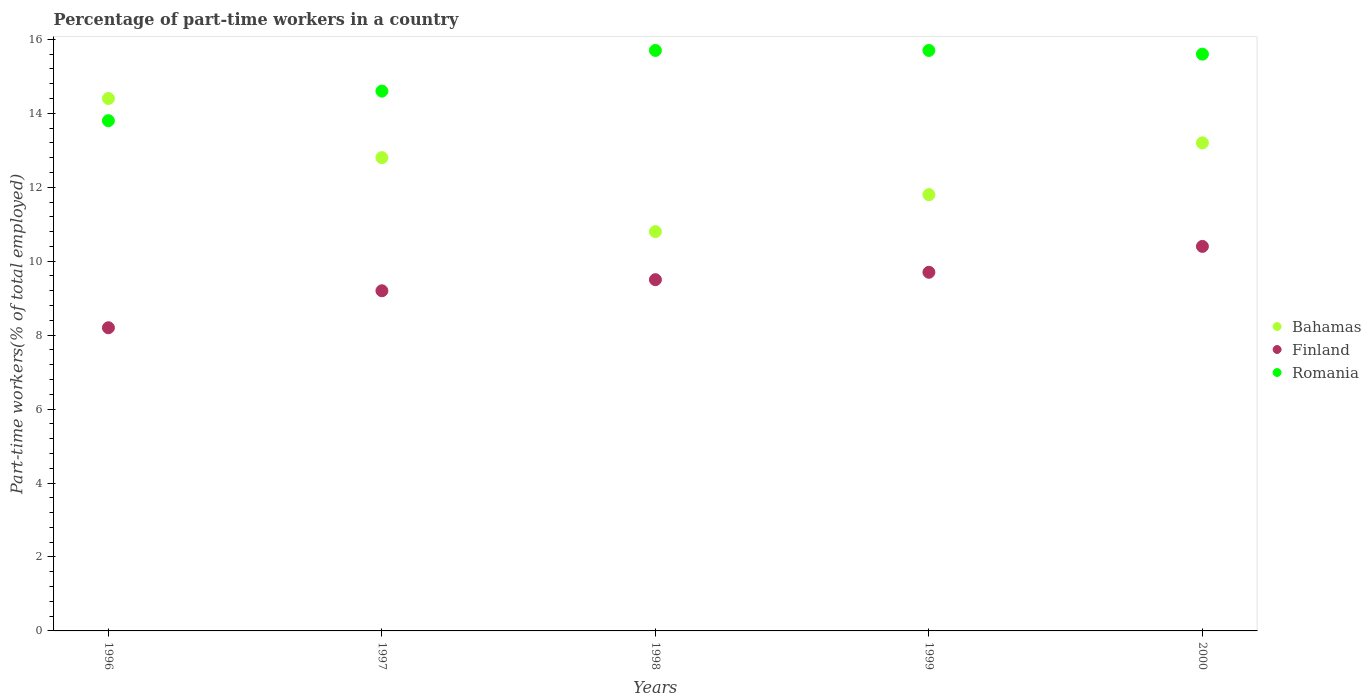Is the number of dotlines equal to the number of legend labels?
Offer a very short reply. Yes. What is the percentage of part-time workers in Bahamas in 1997?
Your response must be concise. 12.8. Across all years, what is the maximum percentage of part-time workers in Finland?
Give a very brief answer. 10.4. Across all years, what is the minimum percentage of part-time workers in Finland?
Offer a very short reply. 8.2. In which year was the percentage of part-time workers in Finland minimum?
Your answer should be very brief. 1996. What is the total percentage of part-time workers in Finland in the graph?
Give a very brief answer. 47. What is the difference between the percentage of part-time workers in Bahamas in 1996 and that in 1997?
Your response must be concise. 1.6. What is the difference between the percentage of part-time workers in Finland in 1998 and the percentage of part-time workers in Bahamas in 1997?
Provide a succinct answer. -3.3. What is the average percentage of part-time workers in Bahamas per year?
Make the answer very short. 12.6. In the year 1996, what is the difference between the percentage of part-time workers in Finland and percentage of part-time workers in Bahamas?
Ensure brevity in your answer.  -6.2. In how many years, is the percentage of part-time workers in Romania greater than 8.8 %?
Offer a very short reply. 5. What is the ratio of the percentage of part-time workers in Romania in 1997 to that in 1999?
Your answer should be very brief. 0.93. What is the difference between the highest and the second highest percentage of part-time workers in Romania?
Make the answer very short. 0. What is the difference between the highest and the lowest percentage of part-time workers in Romania?
Provide a succinct answer. 1.9. Is it the case that in every year, the sum of the percentage of part-time workers in Romania and percentage of part-time workers in Finland  is greater than the percentage of part-time workers in Bahamas?
Ensure brevity in your answer.  Yes. How many dotlines are there?
Your answer should be very brief. 3. What is the difference between two consecutive major ticks on the Y-axis?
Ensure brevity in your answer.  2. Are the values on the major ticks of Y-axis written in scientific E-notation?
Offer a terse response. No. Where does the legend appear in the graph?
Give a very brief answer. Center right. How many legend labels are there?
Your response must be concise. 3. What is the title of the graph?
Offer a terse response. Percentage of part-time workers in a country. What is the label or title of the X-axis?
Provide a succinct answer. Years. What is the label or title of the Y-axis?
Offer a very short reply. Part-time workers(% of total employed). What is the Part-time workers(% of total employed) in Bahamas in 1996?
Make the answer very short. 14.4. What is the Part-time workers(% of total employed) in Finland in 1996?
Provide a succinct answer. 8.2. What is the Part-time workers(% of total employed) in Romania in 1996?
Make the answer very short. 13.8. What is the Part-time workers(% of total employed) in Bahamas in 1997?
Offer a terse response. 12.8. What is the Part-time workers(% of total employed) of Finland in 1997?
Make the answer very short. 9.2. What is the Part-time workers(% of total employed) of Romania in 1997?
Provide a short and direct response. 14.6. What is the Part-time workers(% of total employed) in Bahamas in 1998?
Provide a succinct answer. 10.8. What is the Part-time workers(% of total employed) of Finland in 1998?
Provide a succinct answer. 9.5. What is the Part-time workers(% of total employed) of Romania in 1998?
Your response must be concise. 15.7. What is the Part-time workers(% of total employed) in Bahamas in 1999?
Make the answer very short. 11.8. What is the Part-time workers(% of total employed) of Finland in 1999?
Your answer should be compact. 9.7. What is the Part-time workers(% of total employed) in Romania in 1999?
Ensure brevity in your answer.  15.7. What is the Part-time workers(% of total employed) of Bahamas in 2000?
Your response must be concise. 13.2. What is the Part-time workers(% of total employed) in Finland in 2000?
Make the answer very short. 10.4. What is the Part-time workers(% of total employed) of Romania in 2000?
Your answer should be very brief. 15.6. Across all years, what is the maximum Part-time workers(% of total employed) of Bahamas?
Provide a succinct answer. 14.4. Across all years, what is the maximum Part-time workers(% of total employed) of Finland?
Keep it short and to the point. 10.4. Across all years, what is the maximum Part-time workers(% of total employed) in Romania?
Offer a terse response. 15.7. Across all years, what is the minimum Part-time workers(% of total employed) of Bahamas?
Ensure brevity in your answer.  10.8. Across all years, what is the minimum Part-time workers(% of total employed) of Finland?
Your answer should be very brief. 8.2. Across all years, what is the minimum Part-time workers(% of total employed) of Romania?
Your answer should be very brief. 13.8. What is the total Part-time workers(% of total employed) of Bahamas in the graph?
Keep it short and to the point. 63. What is the total Part-time workers(% of total employed) of Finland in the graph?
Provide a succinct answer. 47. What is the total Part-time workers(% of total employed) of Romania in the graph?
Give a very brief answer. 75.4. What is the difference between the Part-time workers(% of total employed) of Bahamas in 1996 and that in 1997?
Keep it short and to the point. 1.6. What is the difference between the Part-time workers(% of total employed) of Bahamas in 1996 and that in 1998?
Your answer should be compact. 3.6. What is the difference between the Part-time workers(% of total employed) in Finland in 1996 and that in 1998?
Ensure brevity in your answer.  -1.3. What is the difference between the Part-time workers(% of total employed) in Bahamas in 1996 and that in 2000?
Your response must be concise. 1.2. What is the difference between the Part-time workers(% of total employed) in Finland in 1996 and that in 2000?
Your answer should be very brief. -2.2. What is the difference between the Part-time workers(% of total employed) of Romania in 1996 and that in 2000?
Make the answer very short. -1.8. What is the difference between the Part-time workers(% of total employed) in Bahamas in 1997 and that in 1998?
Keep it short and to the point. 2. What is the difference between the Part-time workers(% of total employed) in Finland in 1997 and that in 1998?
Provide a succinct answer. -0.3. What is the difference between the Part-time workers(% of total employed) in Romania in 1997 and that in 1998?
Ensure brevity in your answer.  -1.1. What is the difference between the Part-time workers(% of total employed) of Finland in 1997 and that in 1999?
Make the answer very short. -0.5. What is the difference between the Part-time workers(% of total employed) in Romania in 1997 and that in 1999?
Offer a very short reply. -1.1. What is the difference between the Part-time workers(% of total employed) of Romania in 1997 and that in 2000?
Ensure brevity in your answer.  -1. What is the difference between the Part-time workers(% of total employed) of Bahamas in 1998 and that in 2000?
Keep it short and to the point. -2.4. What is the difference between the Part-time workers(% of total employed) in Romania in 1998 and that in 2000?
Provide a short and direct response. 0.1. What is the difference between the Part-time workers(% of total employed) of Bahamas in 1996 and the Part-time workers(% of total employed) of Finland in 1997?
Ensure brevity in your answer.  5.2. What is the difference between the Part-time workers(% of total employed) of Bahamas in 1996 and the Part-time workers(% of total employed) of Finland in 1998?
Offer a terse response. 4.9. What is the difference between the Part-time workers(% of total employed) of Bahamas in 1996 and the Part-time workers(% of total employed) of Romania in 1998?
Provide a short and direct response. -1.3. What is the difference between the Part-time workers(% of total employed) in Finland in 1996 and the Part-time workers(% of total employed) in Romania in 1999?
Offer a terse response. -7.5. What is the difference between the Part-time workers(% of total employed) of Finland in 1996 and the Part-time workers(% of total employed) of Romania in 2000?
Provide a succinct answer. -7.4. What is the difference between the Part-time workers(% of total employed) of Bahamas in 1997 and the Part-time workers(% of total employed) of Finland in 1998?
Provide a short and direct response. 3.3. What is the difference between the Part-time workers(% of total employed) of Finland in 1997 and the Part-time workers(% of total employed) of Romania in 1998?
Make the answer very short. -6.5. What is the difference between the Part-time workers(% of total employed) in Bahamas in 1997 and the Part-time workers(% of total employed) in Romania in 1999?
Your answer should be very brief. -2.9. What is the difference between the Part-time workers(% of total employed) in Finland in 1997 and the Part-time workers(% of total employed) in Romania in 1999?
Your response must be concise. -6.5. What is the difference between the Part-time workers(% of total employed) in Bahamas in 1997 and the Part-time workers(% of total employed) in Finland in 2000?
Your answer should be compact. 2.4. What is the difference between the Part-time workers(% of total employed) of Finland in 1998 and the Part-time workers(% of total employed) of Romania in 1999?
Offer a very short reply. -6.2. What is the difference between the Part-time workers(% of total employed) in Bahamas in 1998 and the Part-time workers(% of total employed) in Finland in 2000?
Your response must be concise. 0.4. What is the difference between the Part-time workers(% of total employed) in Finland in 1998 and the Part-time workers(% of total employed) in Romania in 2000?
Make the answer very short. -6.1. What is the difference between the Part-time workers(% of total employed) of Bahamas in 1999 and the Part-time workers(% of total employed) of Finland in 2000?
Give a very brief answer. 1.4. What is the average Part-time workers(% of total employed) of Romania per year?
Give a very brief answer. 15.08. In the year 1996, what is the difference between the Part-time workers(% of total employed) of Bahamas and Part-time workers(% of total employed) of Romania?
Provide a succinct answer. 0.6. In the year 1997, what is the difference between the Part-time workers(% of total employed) of Bahamas and Part-time workers(% of total employed) of Finland?
Your response must be concise. 3.6. In the year 1997, what is the difference between the Part-time workers(% of total employed) in Finland and Part-time workers(% of total employed) in Romania?
Give a very brief answer. -5.4. In the year 1998, what is the difference between the Part-time workers(% of total employed) in Bahamas and Part-time workers(% of total employed) in Finland?
Your response must be concise. 1.3. In the year 1999, what is the difference between the Part-time workers(% of total employed) of Bahamas and Part-time workers(% of total employed) of Romania?
Your answer should be very brief. -3.9. In the year 2000, what is the difference between the Part-time workers(% of total employed) of Bahamas and Part-time workers(% of total employed) of Romania?
Your answer should be very brief. -2.4. In the year 2000, what is the difference between the Part-time workers(% of total employed) in Finland and Part-time workers(% of total employed) in Romania?
Your answer should be very brief. -5.2. What is the ratio of the Part-time workers(% of total employed) in Finland in 1996 to that in 1997?
Offer a terse response. 0.89. What is the ratio of the Part-time workers(% of total employed) of Romania in 1996 to that in 1997?
Give a very brief answer. 0.95. What is the ratio of the Part-time workers(% of total employed) in Finland in 1996 to that in 1998?
Keep it short and to the point. 0.86. What is the ratio of the Part-time workers(% of total employed) in Romania in 1996 to that in 1998?
Keep it short and to the point. 0.88. What is the ratio of the Part-time workers(% of total employed) of Bahamas in 1996 to that in 1999?
Offer a very short reply. 1.22. What is the ratio of the Part-time workers(% of total employed) of Finland in 1996 to that in 1999?
Provide a succinct answer. 0.85. What is the ratio of the Part-time workers(% of total employed) of Romania in 1996 to that in 1999?
Make the answer very short. 0.88. What is the ratio of the Part-time workers(% of total employed) in Bahamas in 1996 to that in 2000?
Your answer should be compact. 1.09. What is the ratio of the Part-time workers(% of total employed) in Finland in 1996 to that in 2000?
Your response must be concise. 0.79. What is the ratio of the Part-time workers(% of total employed) in Romania in 1996 to that in 2000?
Keep it short and to the point. 0.88. What is the ratio of the Part-time workers(% of total employed) of Bahamas in 1997 to that in 1998?
Give a very brief answer. 1.19. What is the ratio of the Part-time workers(% of total employed) of Finland in 1997 to that in 1998?
Make the answer very short. 0.97. What is the ratio of the Part-time workers(% of total employed) of Romania in 1997 to that in 1998?
Ensure brevity in your answer.  0.93. What is the ratio of the Part-time workers(% of total employed) in Bahamas in 1997 to that in 1999?
Ensure brevity in your answer.  1.08. What is the ratio of the Part-time workers(% of total employed) in Finland in 1997 to that in 1999?
Offer a very short reply. 0.95. What is the ratio of the Part-time workers(% of total employed) in Romania in 1997 to that in 1999?
Provide a short and direct response. 0.93. What is the ratio of the Part-time workers(% of total employed) in Bahamas in 1997 to that in 2000?
Make the answer very short. 0.97. What is the ratio of the Part-time workers(% of total employed) in Finland in 1997 to that in 2000?
Offer a very short reply. 0.88. What is the ratio of the Part-time workers(% of total employed) of Romania in 1997 to that in 2000?
Make the answer very short. 0.94. What is the ratio of the Part-time workers(% of total employed) in Bahamas in 1998 to that in 1999?
Provide a succinct answer. 0.92. What is the ratio of the Part-time workers(% of total employed) in Finland in 1998 to that in 1999?
Your answer should be compact. 0.98. What is the ratio of the Part-time workers(% of total employed) in Romania in 1998 to that in 1999?
Your answer should be compact. 1. What is the ratio of the Part-time workers(% of total employed) in Bahamas in 1998 to that in 2000?
Offer a very short reply. 0.82. What is the ratio of the Part-time workers(% of total employed) in Finland in 1998 to that in 2000?
Offer a very short reply. 0.91. What is the ratio of the Part-time workers(% of total employed) of Romania in 1998 to that in 2000?
Keep it short and to the point. 1.01. What is the ratio of the Part-time workers(% of total employed) in Bahamas in 1999 to that in 2000?
Offer a very short reply. 0.89. What is the ratio of the Part-time workers(% of total employed) of Finland in 1999 to that in 2000?
Keep it short and to the point. 0.93. What is the ratio of the Part-time workers(% of total employed) of Romania in 1999 to that in 2000?
Your answer should be compact. 1.01. What is the difference between the highest and the second highest Part-time workers(% of total employed) of Bahamas?
Offer a terse response. 1.2. What is the difference between the highest and the second highest Part-time workers(% of total employed) of Finland?
Make the answer very short. 0.7. What is the difference between the highest and the lowest Part-time workers(% of total employed) of Bahamas?
Make the answer very short. 3.6. What is the difference between the highest and the lowest Part-time workers(% of total employed) of Romania?
Your answer should be very brief. 1.9. 